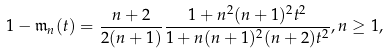<formula> <loc_0><loc_0><loc_500><loc_500>1 - \mathfrak { m } _ { n } ( t ) = \frac { n + 2 } { 2 ( n + 1 ) } \frac { 1 + n ^ { 2 } ( n + 1 ) ^ { 2 } t ^ { 2 } } { 1 + n ( n + 1 ) ^ { 2 } ( n + 2 ) t ^ { 2 } } , n \geq 1 ,</formula> 